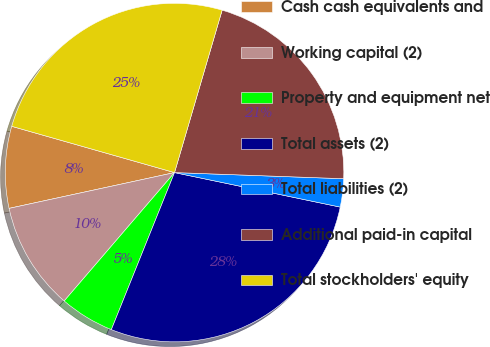Convert chart to OTSL. <chart><loc_0><loc_0><loc_500><loc_500><pie_chart><fcel>Cash cash equivalents and<fcel>Working capital (2)<fcel>Property and equipment net<fcel>Total assets (2)<fcel>Total liabilities (2)<fcel>Additional paid-in capital<fcel>Total stockholders' equity<nl><fcel>7.8%<fcel>10.31%<fcel>5.21%<fcel>27.82%<fcel>2.69%<fcel>21.04%<fcel>25.13%<nl></chart> 